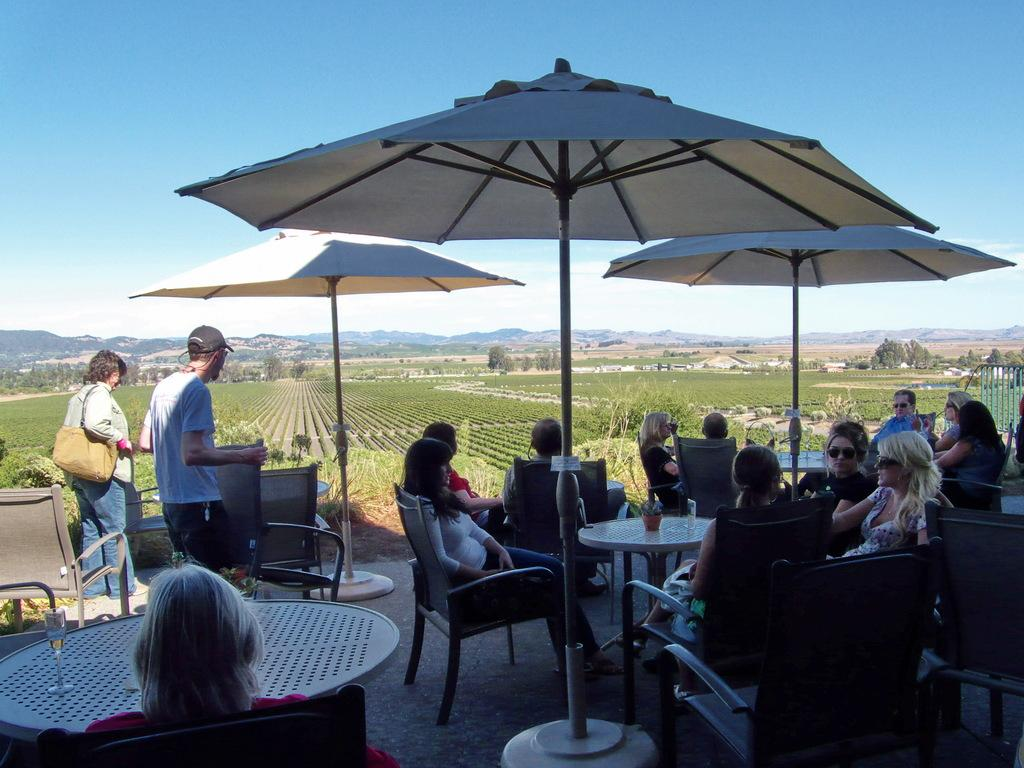What are the people in the image doing? There is a group of people seated in the image. Are there any people standing in the image? Yes, there are two people standing in the image. What might be used to provide shade in the image? Umbrellas are visible in the image. What type of natural vegetation is present in the image? There are trees around the area in the image. What type of creature can be seen climbing the arch in the image? There is no arch present in the image, and therefore no creature can be seen climbing it. 